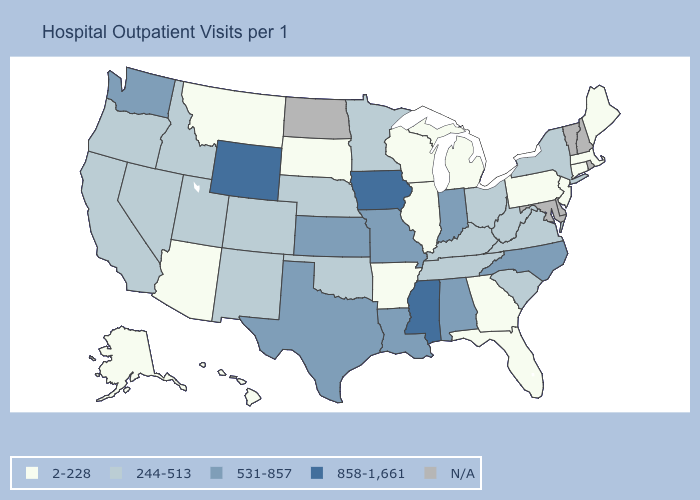Does Missouri have the lowest value in the MidWest?
Concise answer only. No. Is the legend a continuous bar?
Quick response, please. No. What is the highest value in states that border New Hampshire?
Quick response, please. 2-228. How many symbols are there in the legend?
Short answer required. 5. What is the value of New Hampshire?
Write a very short answer. N/A. Is the legend a continuous bar?
Concise answer only. No. Does Oregon have the lowest value in the West?
Be succinct. No. What is the value of Iowa?
Short answer required. 858-1,661. Among the states that border California , does Oregon have the lowest value?
Answer briefly. No. What is the value of Arkansas?
Concise answer only. 2-228. What is the highest value in the USA?
Answer briefly. 858-1,661. Does the first symbol in the legend represent the smallest category?
Write a very short answer. Yes. Which states have the highest value in the USA?
Short answer required. Iowa, Mississippi, Wyoming. 